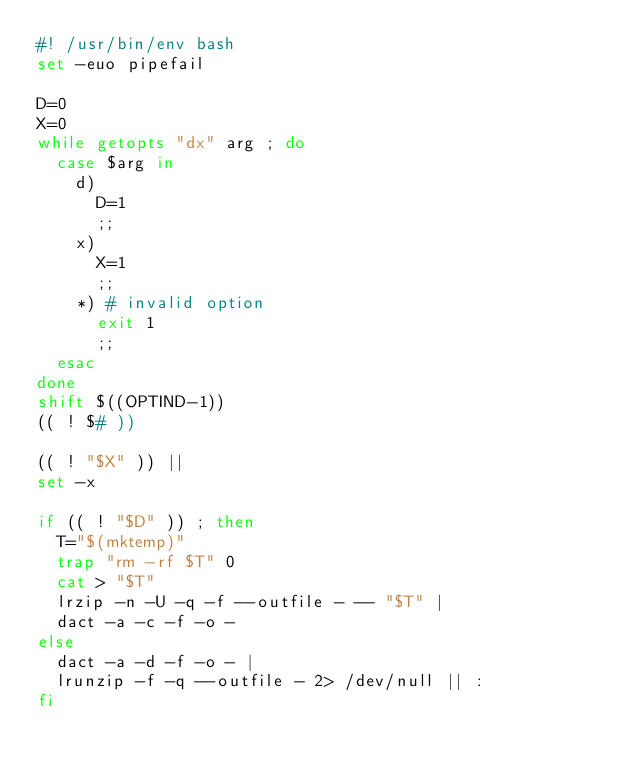<code> <loc_0><loc_0><loc_500><loc_500><_Bash_>#! /usr/bin/env bash
set -euo pipefail

D=0
X=0
while getopts "dx" arg ; do
  case $arg in
    d)
      D=1
      ;;
    x)
      X=1
      ;;
    *) # invalid option
      exit 1
      ;;
  esac
done
shift $((OPTIND-1))
(( ! $# ))

(( ! "$X" )) ||
set -x

if (( ! "$D" )) ; then
  T="$(mktemp)"
  trap "rm -rf $T" 0
  cat > "$T"
  lrzip -n -U -q -f --outfile - -- "$T" |
  dact -a -c -f -o -
else
  dact -a -d -f -o - |
  lrunzip -f -q --outfile - 2> /dev/null || :
fi

</code> 